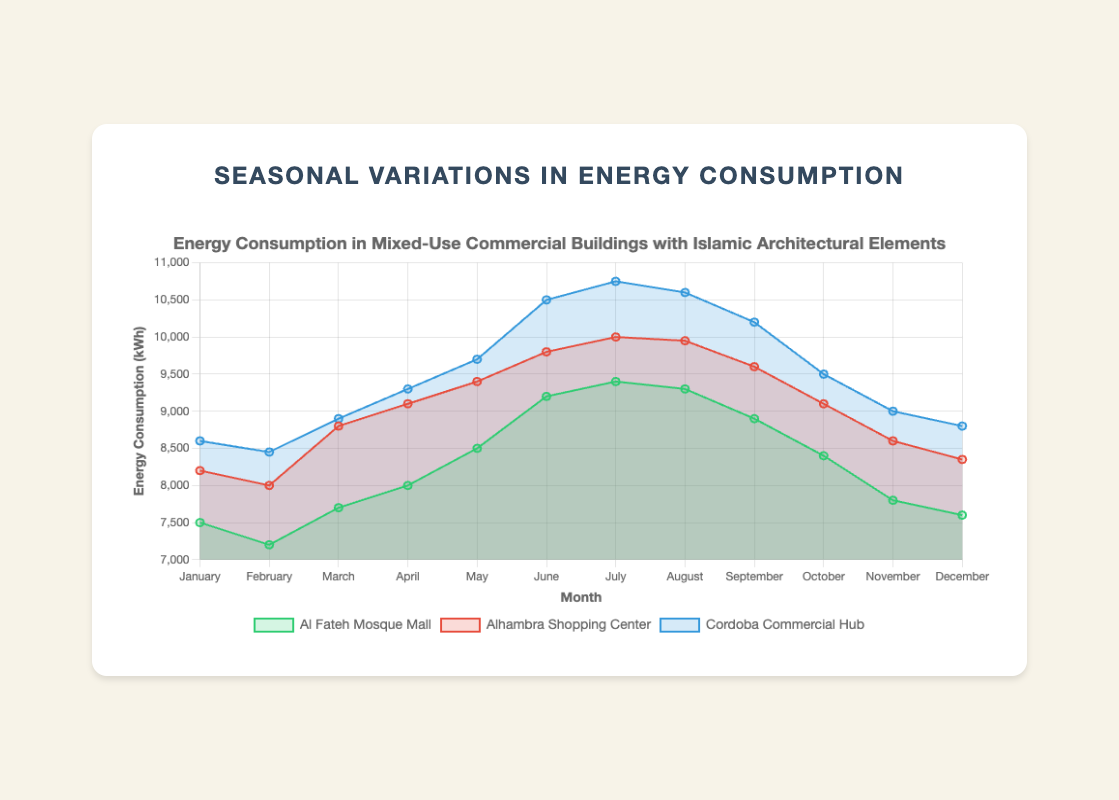Which building has the highest energy consumption in July? To determine which building has the highest energy consumption in July, locate July on the x-axis and compare the values for each building dataset. Cordoba Commercial Hub has the highest value at 10,750 kWh.
Answer: Cordoba Commercial Hub How much more energy does Cordoba Commercial Hub consume in June compared to Al Fateh Mosque Mall in the same month? Identify the energy consumption values for Cordoba Commercial Hub and Al Fateh Mosque Mall in June. Cordoba Commercial Hub consumes 10,500 kWh and Al Fateh Mosque Mall consumes 9,200 kWh. The difference is 10,500 - 9,200 = 1,300 kWh.
Answer: 1,300 kWh What is the average monthly energy consumption for Alhambra Shopping Center from January to December? Sum the monthly energy consumption values for Alhambra Shopping Center and divide by 12. (8200 + 8000 + 8800 + 9100 + 9400 + 9800 + 10000 + 9950 + 9600 + 9100 + 8600 + 8350) / 12 = 9192.5 kWh.
Answer: 9192.5 kWh Which building has the least variational trend in energy consumption throughout the year? Observe the fluctuation patterns of the three buildings. Al Fateh Mosque Mall has a less steep and more consistent trend compared to Alhambra Shopping Center and Cordoba Commercial Hub.
Answer: Al Fateh Mosque Mall During which month does Al Fateh Mosque Mall have its peak energy consumption? Locate the highest point on the Al Fateh Mosque Mall's line plot, which occurs in July with 9,400 kWh.
Answer: July Between August and September, which building experienced a decrease in energy consumption? Compare the energy values for August and September across the three buildings. Al Fateh Mosque Mall (9,300 to 8,900), Alhambra Shopping Center (9,950 to 9,600), Cordoba Commercial Hub (10,600 to 10,200). All three buildings experienced a decrease.
Answer: All three buildings What is the total energy consumption of Cordoba Commercial Hub for the first quarter of the year (January to March)? Sum the energy consumption values for January, February, and March for Cordoba Commercial Hub. 8600 + 8450 + 8900 = 25,950 kWh.
Answer: 25,950 kWh In which month is the energy consumption of Alhambra Shopping Center closest to 9,000 kWh? Identify the month where the energy consumption value is nearest to 9,000 kWh. In April, it is 9,100 kWh.
Answer: April How much energy is consumed by Al Fateh Mosque Mall in June and July combined? Add the energy consumption values for June and July for Al Fateh Mosque Mall. 9200 + 9400 = 18,600 kWh.
Answer: 18,600 kWh Compare the energy consumption trend of Alhambra Shopping Center and Cordoba Commercial Hub in the latter half of the year. Which building shows a higher increase? Calculate the difference in energy consumption between July and December for both buildings. For Alhambra Shopping Center, the increase is 8,350 - 10,000 = -1,650 (decrease), while for Cordoba Commercial Hub, it is 8,800 - 10,750 = -1,950 (decrease). Both buildings show a decrease, with Cordoba having a higher negative change.
Answer: Alhambra Shopping Center shows a lesser decrease 